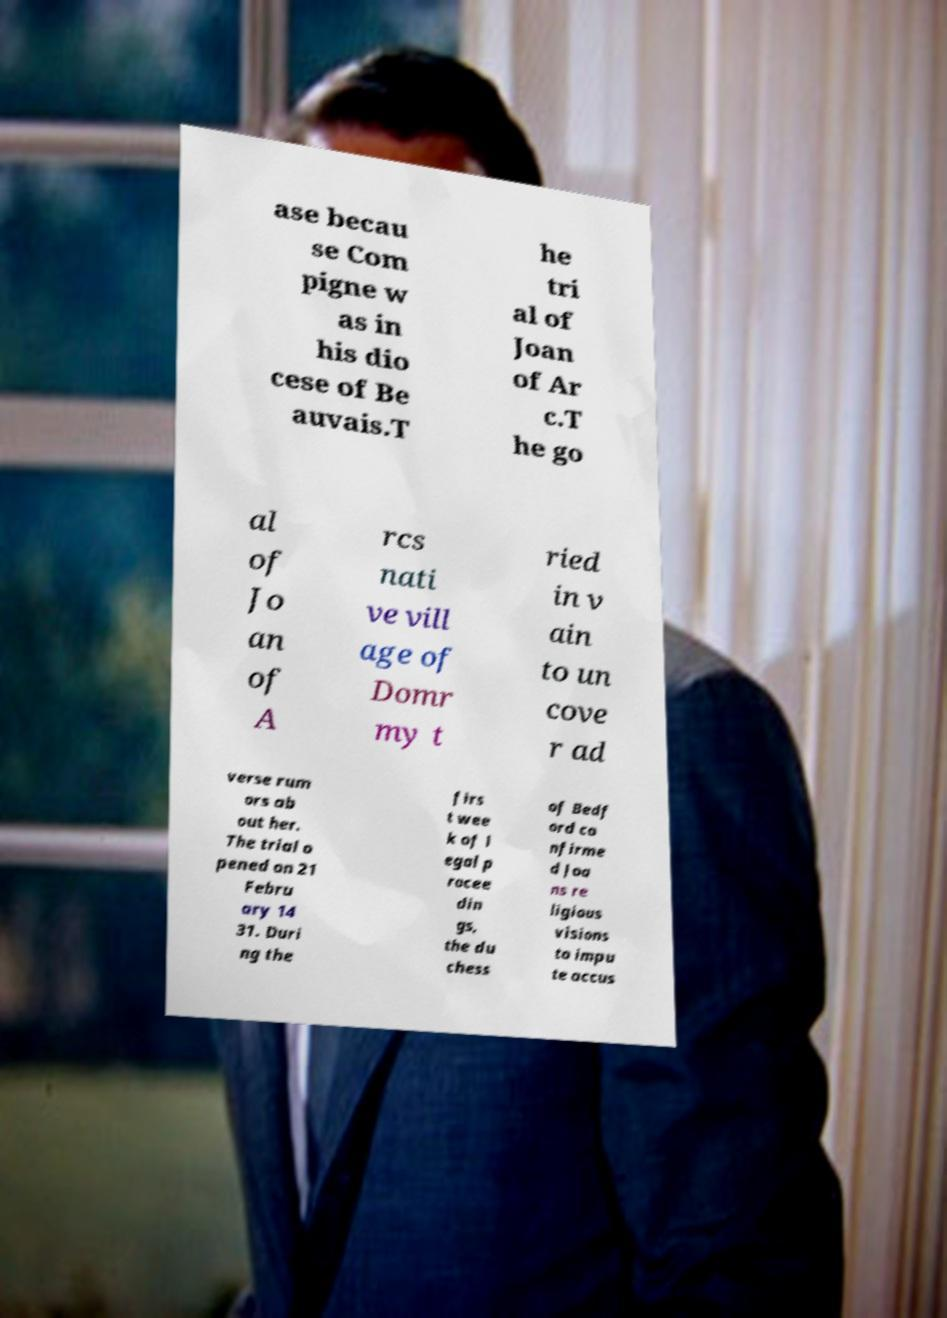Could you assist in decoding the text presented in this image and type it out clearly? ase becau se Com pigne w as in his dio cese of Be auvais.T he tri al of Joan of Ar c.T he go al of Jo an of A rcs nati ve vill age of Domr my t ried in v ain to un cove r ad verse rum ors ab out her. The trial o pened on 21 Febru ary 14 31. Duri ng the firs t wee k of l egal p rocee din gs, the du chess of Bedf ord co nfirme d Joa ns re ligious visions to impu te accus 